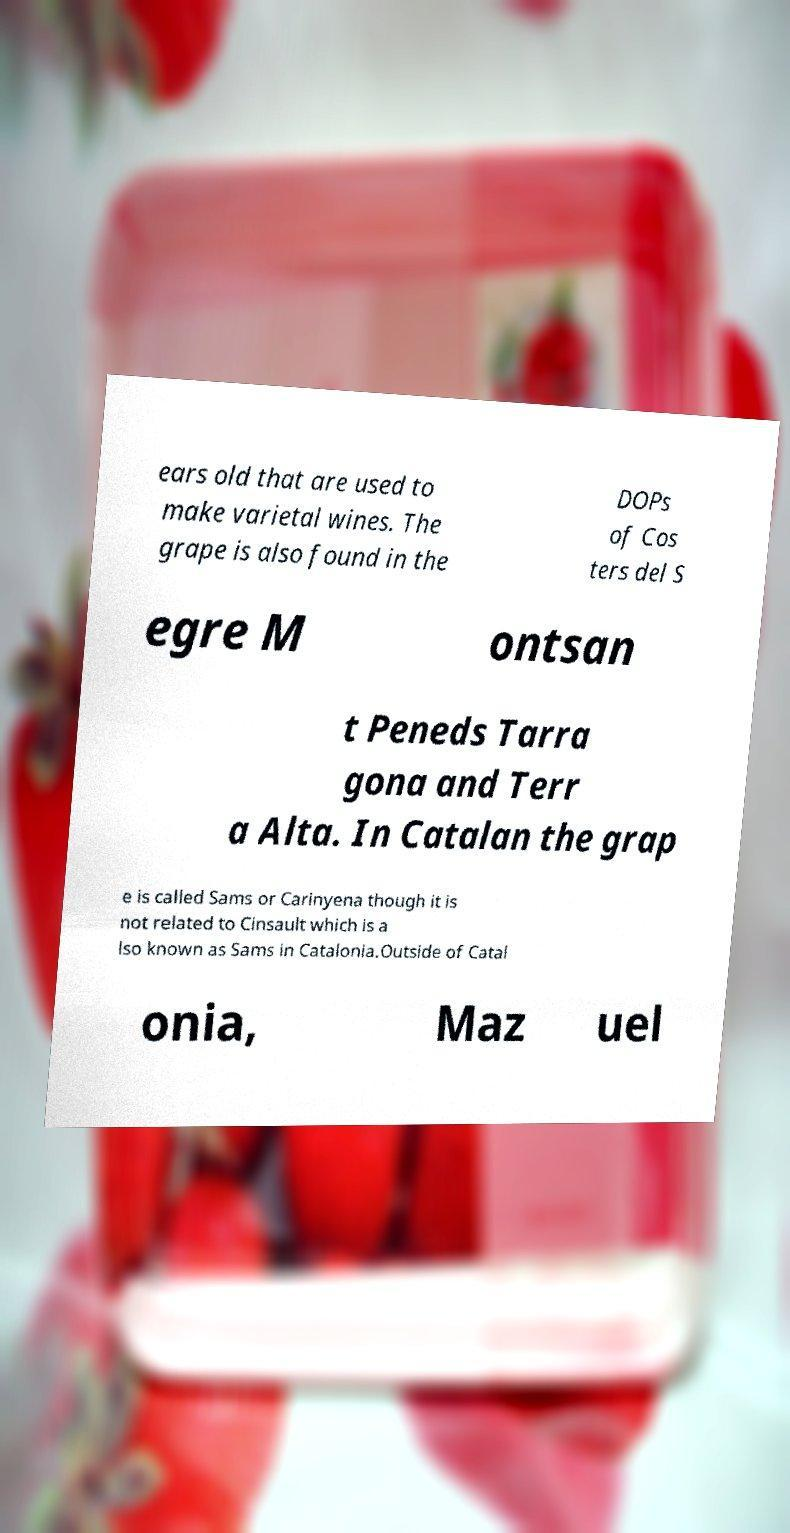For documentation purposes, I need the text within this image transcribed. Could you provide that? ears old that are used to make varietal wines. The grape is also found in the DOPs of Cos ters del S egre M ontsan t Peneds Tarra gona and Terr a Alta. In Catalan the grap e is called Sams or Carinyena though it is not related to Cinsault which is a lso known as Sams in Catalonia.Outside of Catal onia, Maz uel 